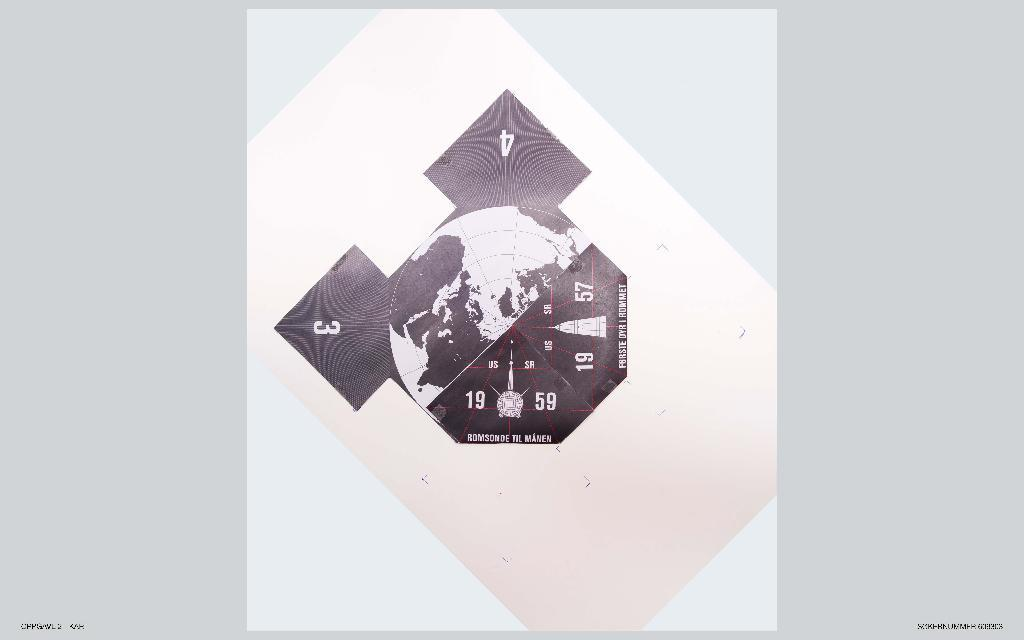What is the main subject of the image? The main subject of the image is a picture of a globe. Are there any distinguishing features on the globe? Yes, the globe has numbers on it. What type of haircut does the plate have in the image? There is no plate or haircut present in the image; it features a picture of a globe with numbers on it. 